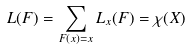<formula> <loc_0><loc_0><loc_500><loc_500>L ( F ) = \sum _ { F ( x ) = x } L _ { x } ( F ) = \chi ( X )</formula> 